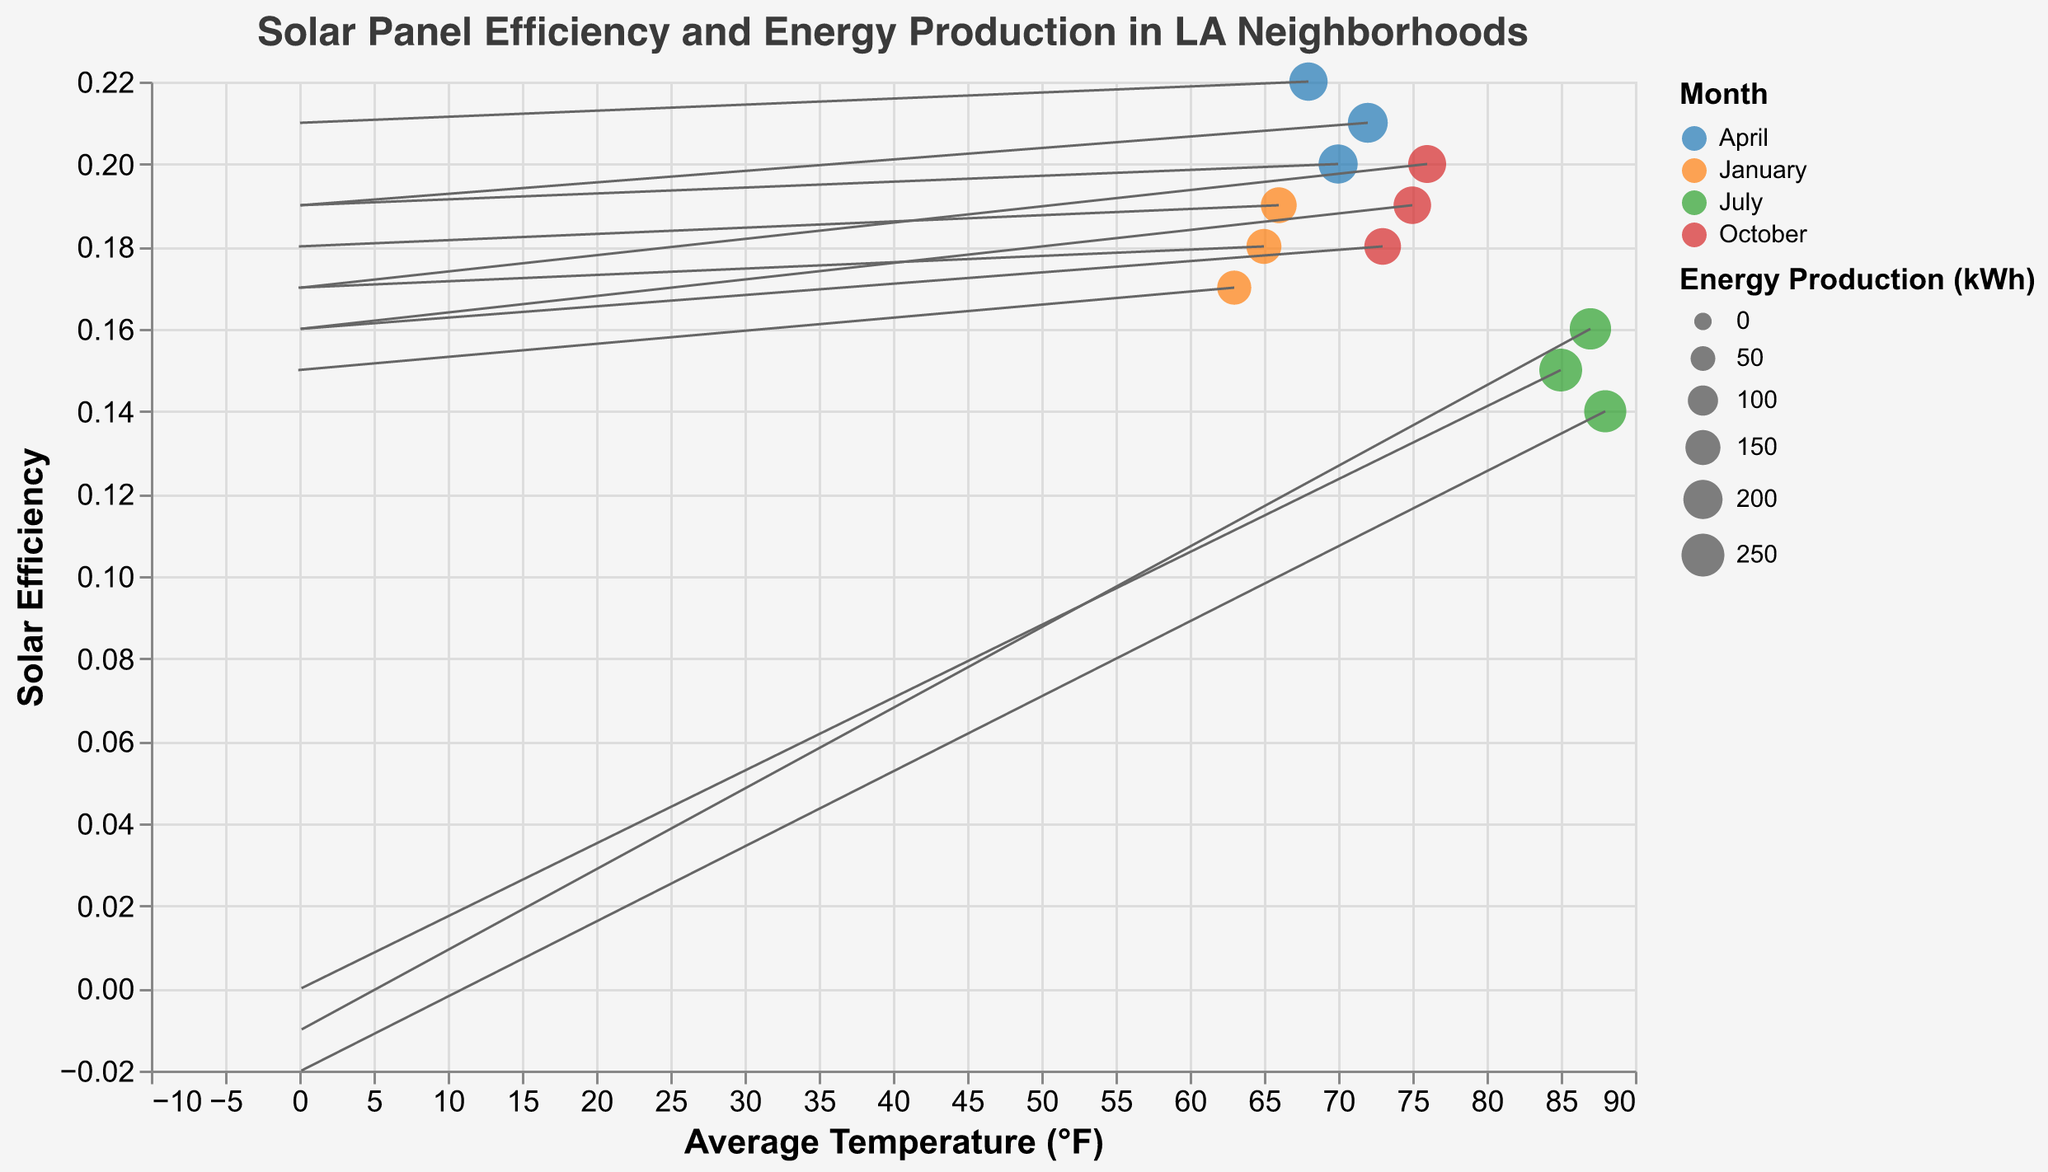What is the average temperature recorded in July? The average temperatures in July for the neighborhoods are 85°F (Downtown LA), 88°F (Glendale), and 87°F (Burbank). Summing these gives (85 + 88 + 87) = 260. The average is 260 / 3 = 86.67°F.
Answer: 86.67°F Which neighborhood has the highest solar efficiency in April? According to the data, the neighborhoods in April are Beverly Hills (0.20), Hollywood (0.21), and Venice (0.22). Venice has the highest solar efficiency of 0.22.
Answer: Venice What is the relationship between temperature and solar efficiency in the dataset? Generally, as the temperature increases, solar efficiency seems to show a slightly decreasing trend. This is evident from points like Glendale in July with higher temperatures (88°F) and lower efficiency (0.14), while Venice in April has a lower temperature (68°F) with higher efficiency (0.22).
Answer: Inverse relationship Which month is associated with the highest average solar efficiency? By comparing the solar efficiencies in different months, January (0.18, 0.17, 0.19), April (0.20, 0.21, 0.22), July (0.15, 0.14, 0.16), and October (0.19, 0.18, 0.20), April has the highest average efficiency, as all its values are above 0.20.
Answer: April How does energy production compare in January across different neighborhoods? In January, Santa Monica produces 150 kWh, Malibu 140 kWh, and Culver City 160 kWh. Culver City has the highest production, followed by Santa Monica, with Malibu having the least.
Answer: Culver City produces the most What pattern do the efficiency vectors in January show? Most vectors in January point upwards with a negative x component, indicating initial lower efficiencies improving moderately in colder temperatures, e.g., Santa Monica (-0.05, 0.17), Malibu (-0.07, 0.15), and Culver City (-0.03, 0.18).
Answer: Upwards with a negative x component Compare the energy production in Beverly Hills in April with Glendale in July. In April, Beverly Hills produces 200 kWh. In July, Glendale produces 240 kWh. Comparing these two, Glendale produces more energy than Beverly Hills.
Answer: Glendale produces more Which neighborhood and month combination has the lowest solar efficiency? According to the data, Glendale in July has the lowest solar efficiency with a value of 0.14.
Answer: Glendale in July What trend do you see in average temperature values between Malibu and Santa Monica across their respective months? In January, Malibu has an average temperature of 63°F, while Santa Monica has 65°F. The trend suggests slightly higher temperatures in Santa Monica compared to Malibu in January.
Answer: Santa Monica is slightly warmer in January 